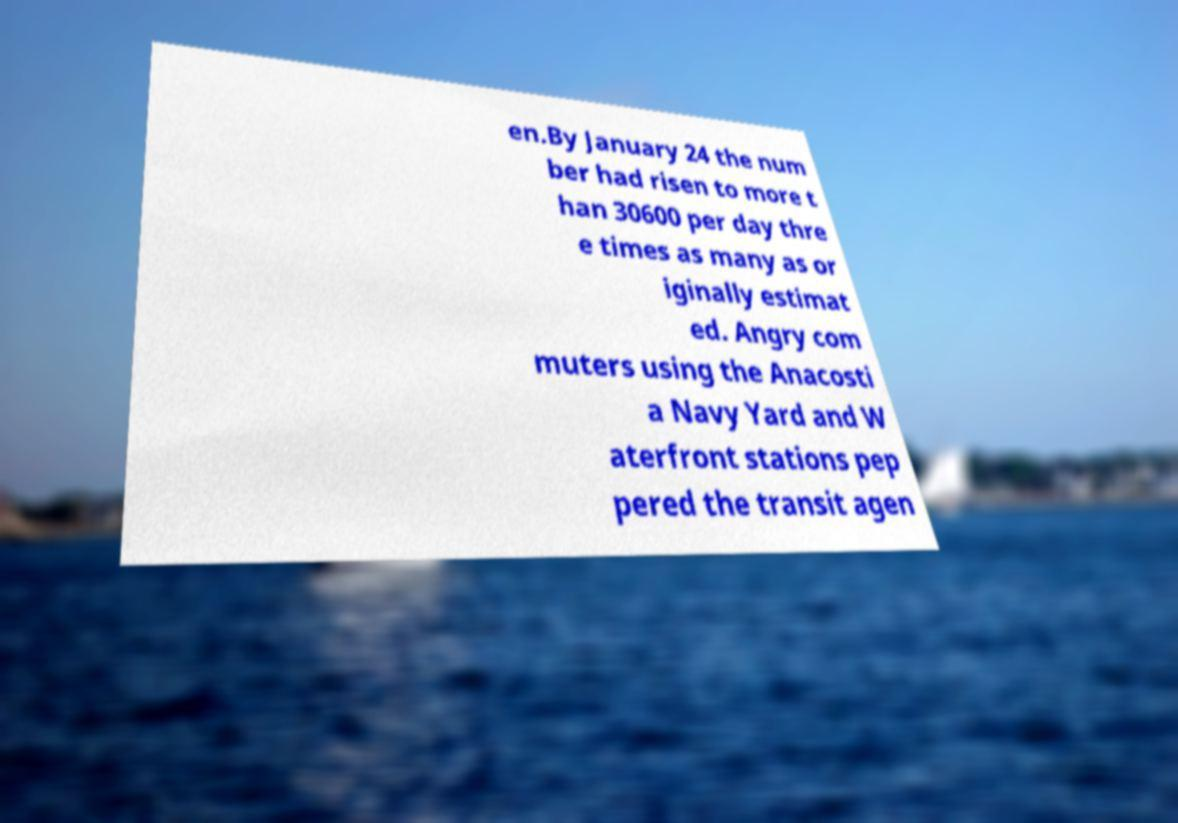Could you assist in decoding the text presented in this image and type it out clearly? en.By January 24 the num ber had risen to more t han 30600 per day thre e times as many as or iginally estimat ed. Angry com muters using the Anacosti a Navy Yard and W aterfront stations pep pered the transit agen 